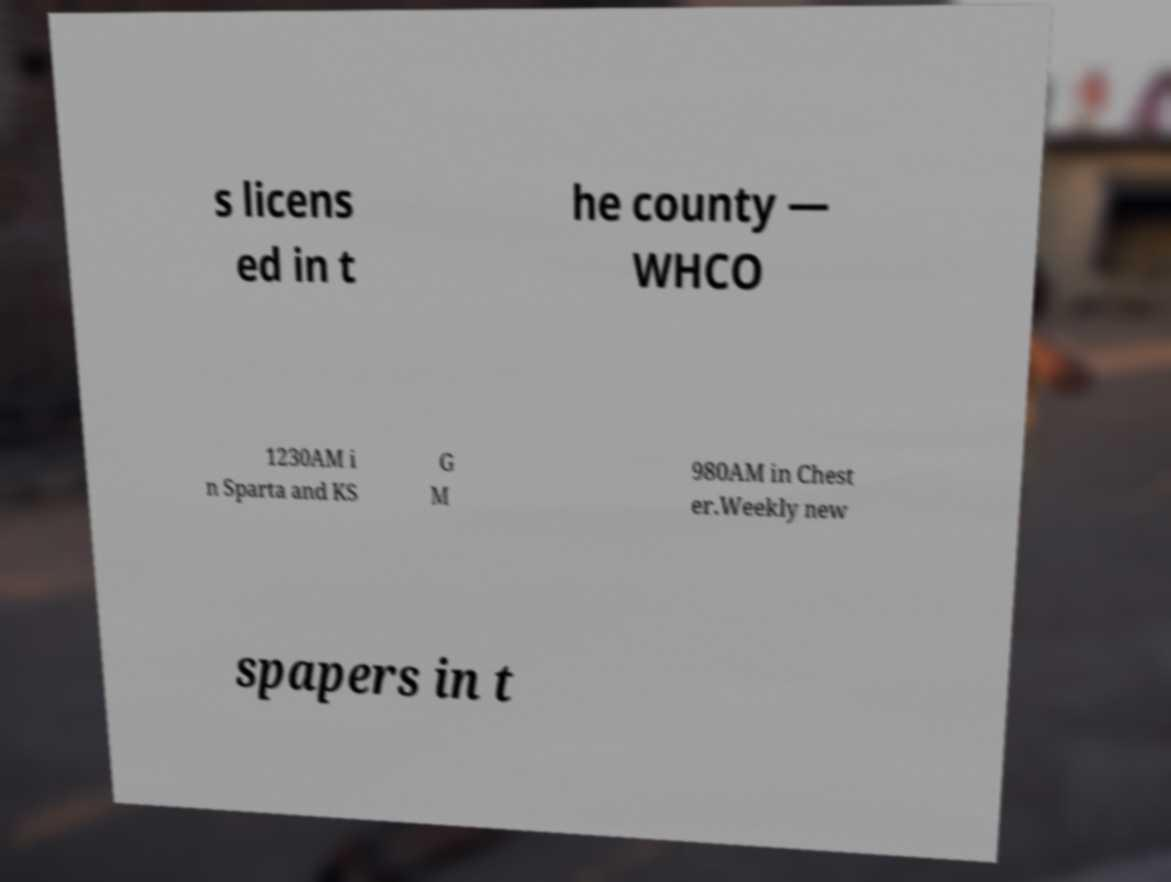Please identify and transcribe the text found in this image. s licens ed in t he county — WHCO 1230AM i n Sparta and KS G M 980AM in Chest er.Weekly new spapers in t 